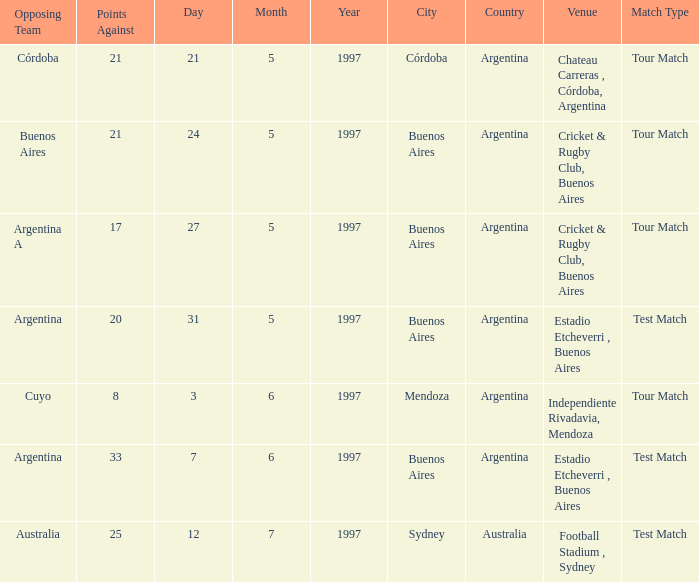What is the status of the match held on 12/7/1997? Test Match. Could you parse the entire table? {'header': ['Opposing Team', 'Points Against', 'Day', 'Month', 'Year', 'City', 'Country', 'Venue', 'Match Type'], 'rows': [['Córdoba', '21', '21', '5', '1997', 'Córdoba', 'Argentina', 'Chateau Carreras , Córdoba, Argentina', 'Tour Match'], ['Buenos Aires', '21', '24', '5', '1997', 'Buenos Aires', 'Argentina', 'Cricket & Rugby Club, Buenos Aires', 'Tour Match'], ['Argentina A', '17', '27', '5', '1997', 'Buenos Aires', 'Argentina', 'Cricket & Rugby Club, Buenos Aires', 'Tour Match'], ['Argentina', '20', '31', '5', '1997', 'Buenos Aires', 'Argentina', 'Estadio Etcheverri , Buenos Aires', 'Test Match'], ['Cuyo', '8', '3', '6', '1997', 'Mendoza', 'Argentina', 'Independiente Rivadavia, Mendoza', 'Tour Match'], ['Argentina', '33', '7', '6', '1997', 'Buenos Aires', 'Argentina', 'Estadio Etcheverri , Buenos Aires', 'Test Match'], ['Australia', '25', '12', '7', '1997', 'Sydney', 'Australia', 'Football Stadium , Sydney', 'Test Match']]} 